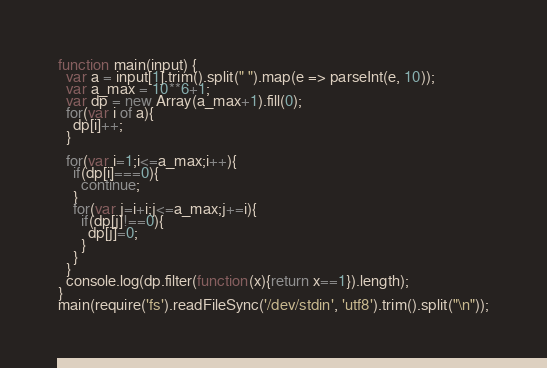Convert code to text. <code><loc_0><loc_0><loc_500><loc_500><_JavaScript_>function main(input) {
  var a = input[1].trim().split(" ").map(e => parseInt(e, 10));
  var a_max = 10**6+1;
  var dp = new Array(a_max+1).fill(0);
  for(var i of a){
    dp[i]++;
  }
 
  for(var i=1;i<=a_max;i++){
    if(dp[i]===0){ 
      continue;
    }
    for(var j=i+i;j<=a_max;j+=i){
      if(dp[j]!==0){
        dp[j]=0;
      }
    }
  }
  console.log(dp.filter(function(x){return x==1}).length);
}
main(require('fs').readFileSync('/dev/stdin', 'utf8').trim().split("\n"));
</code> 